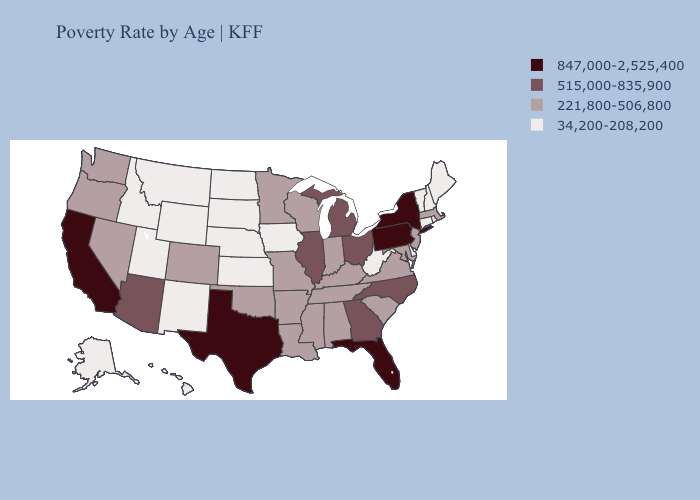Which states have the lowest value in the MidWest?
Answer briefly. Iowa, Kansas, Nebraska, North Dakota, South Dakota. What is the lowest value in states that border Oklahoma?
Concise answer only. 34,200-208,200. Name the states that have a value in the range 847,000-2,525,400?
Write a very short answer. California, Florida, New York, Pennsylvania, Texas. Does Pennsylvania have the same value as California?
Write a very short answer. Yes. Does Texas have the highest value in the USA?
Write a very short answer. Yes. What is the lowest value in states that border West Virginia?
Concise answer only. 221,800-506,800. Name the states that have a value in the range 515,000-835,900?
Concise answer only. Arizona, Georgia, Illinois, Michigan, North Carolina, Ohio. Does New York have the highest value in the USA?
Concise answer only. Yes. Name the states that have a value in the range 34,200-208,200?
Concise answer only. Alaska, Connecticut, Delaware, Hawaii, Idaho, Iowa, Kansas, Maine, Montana, Nebraska, New Hampshire, New Mexico, North Dakota, Rhode Island, South Dakota, Utah, Vermont, West Virginia, Wyoming. What is the value of Georgia?
Write a very short answer. 515,000-835,900. Does Texas have the highest value in the USA?
Short answer required. Yes. Does the first symbol in the legend represent the smallest category?
Quick response, please. No. What is the highest value in the West ?
Concise answer only. 847,000-2,525,400. What is the highest value in the USA?
Be succinct. 847,000-2,525,400. Does Alabama have the highest value in the South?
Answer briefly. No. 